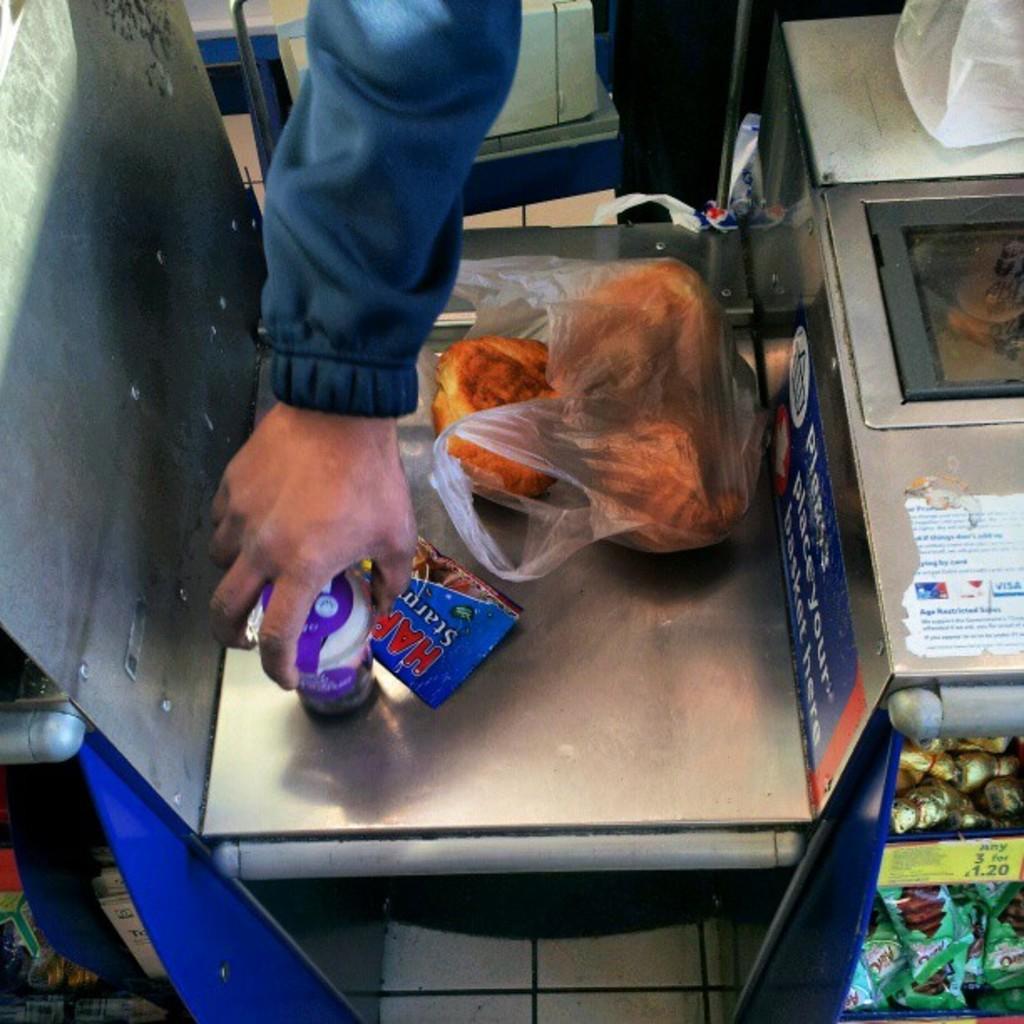Can you describe this image briefly? In the image in the center, we can see one chair. On the chair, we can see one glass, plastic cover, plastic packet and buns. And we can see one person holding glass. In the background we can see chairs, boxes, posters, chocolates, packets and a few other objects. 